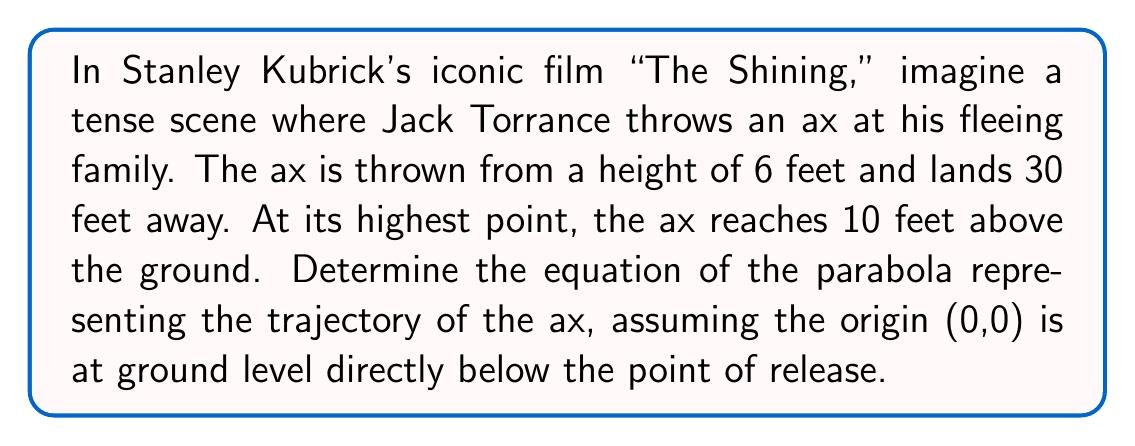Help me with this question. To solve this problem, we'll use the general form of a parabola: $y = ax^2 + bx + c$

Given information:
- Starting point: (0, 6)
- Ending point: (30, 0)
- Vertex: The highest point is 10 feet, but we don't know its x-coordinate yet.

Step 1: Use the starting point to find c.
$6 = a(0)^2 + b(0) + c$
$c = 6$

Step 2: Use the ending point to create an equation.
$0 = a(30)^2 + b(30) + 6$
$0 = 900a + 30b + 6$ ... (Equation 1)

Step 3: Find the axis of symmetry.
The x-coordinate of the vertex is halfway between 0 and 30.
$x = \frac{0 + 30}{2} = 15$

Step 4: Use the vertex point (15, 10) to create another equation.
$10 = a(15)^2 + b(15) + 6$
$4 = 225a + 15b$ ... (Equation 2)

Step 5: Solve the system of equations.
Multiply Equation 2 by 2: $8 = 450a + 30b$
Subtract this from Equation 1: $-8 = 450a$
$a = -\frac{8}{450} = -\frac{4}{225}$

Substitute this back into Equation 2:
$4 = 225(-\frac{4}{225}) + 15b$
$4 = -4 + 15b$
$8 = 15b$
$b = \frac{8}{15}$

Step 6: Construct the equation of the parabola.
$y = -\frac{4}{225}x^2 + \frac{8}{15}x + 6$
Answer: The equation of the parabola representing the trajectory of the ax is:

$$y = -\frac{4}{225}x^2 + \frac{8}{15}x + 6$$ 